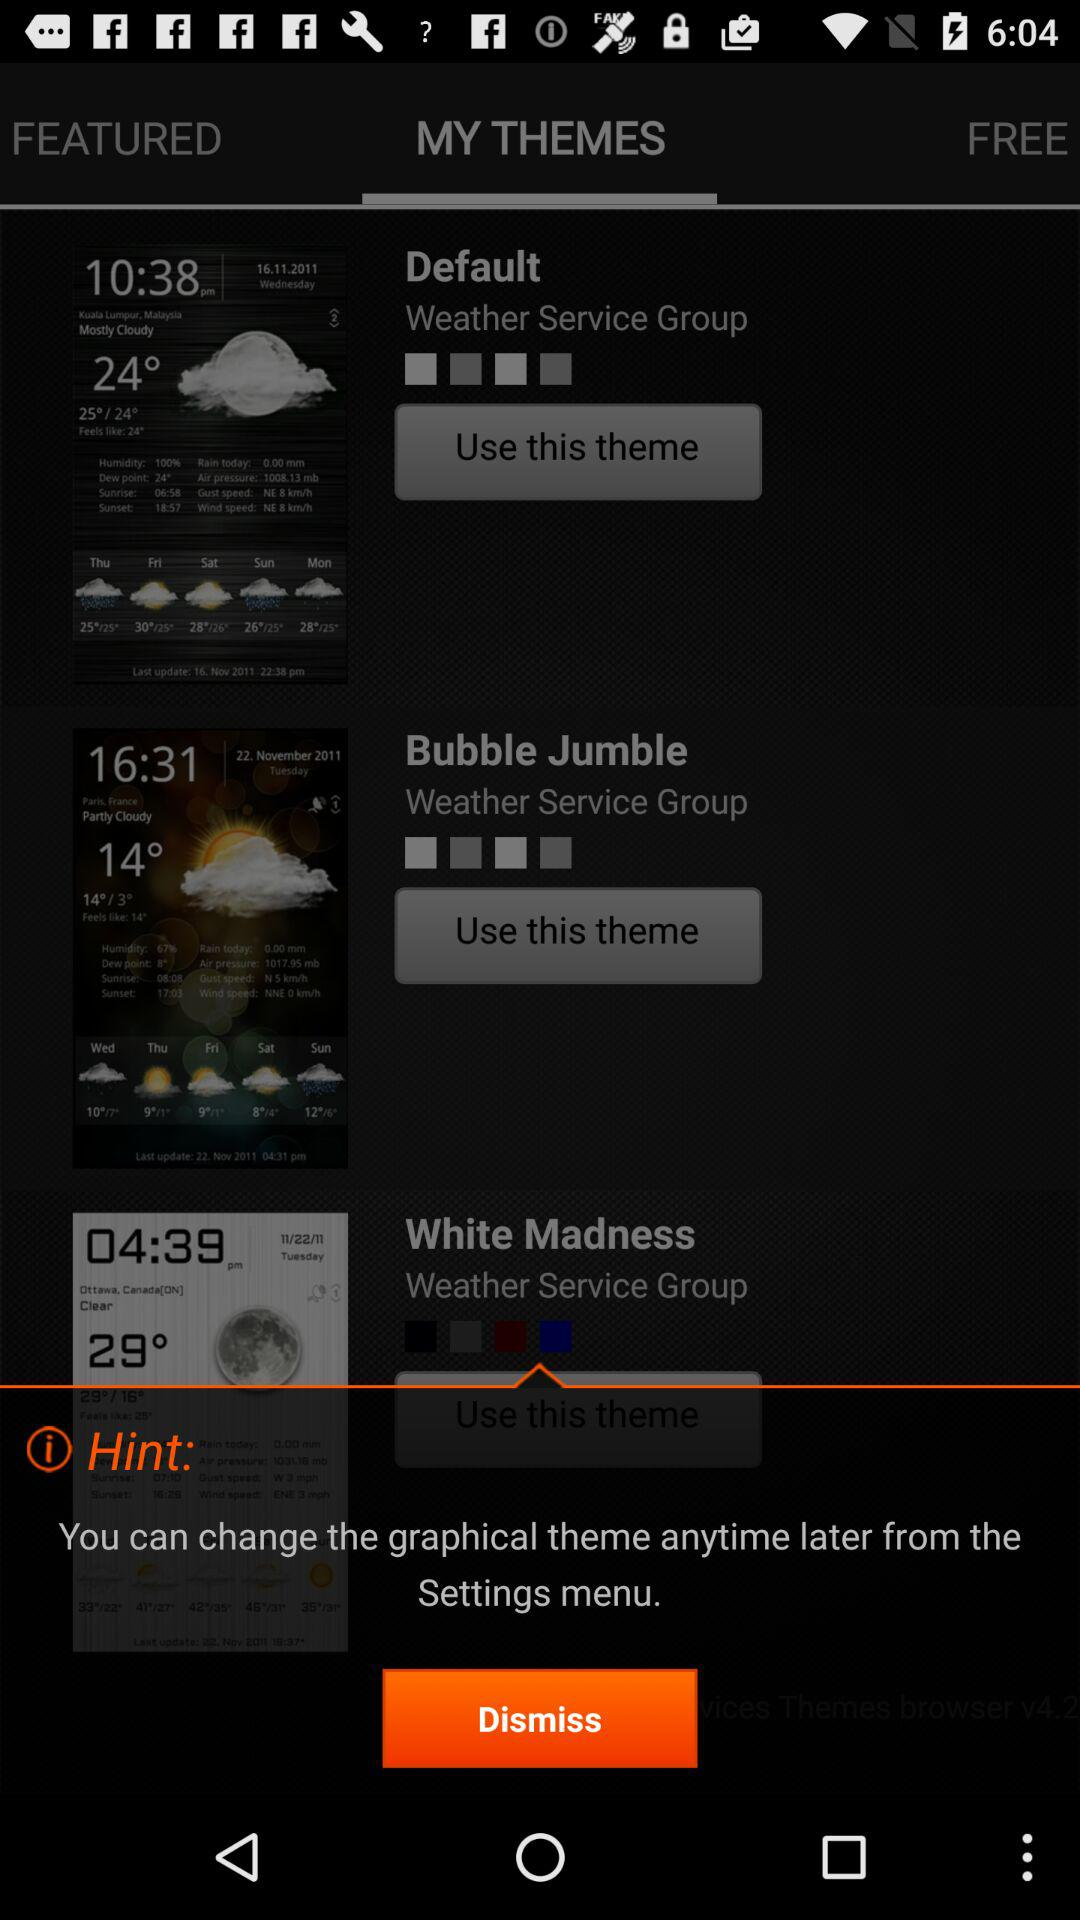How many themes are available?
Answer the question using a single word or phrase. 3 